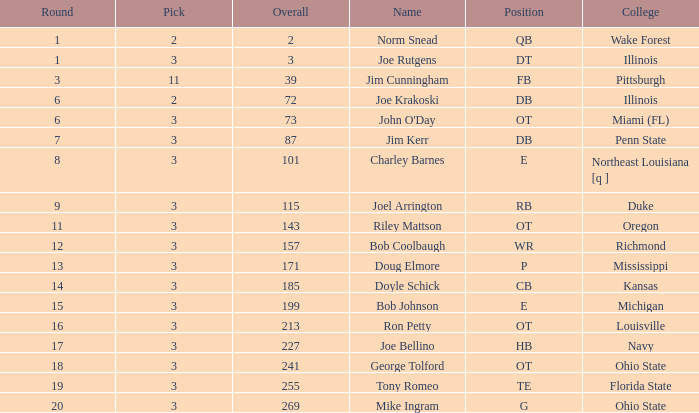How many rounds have john o'day as the name, and a pick less than 3? None. 